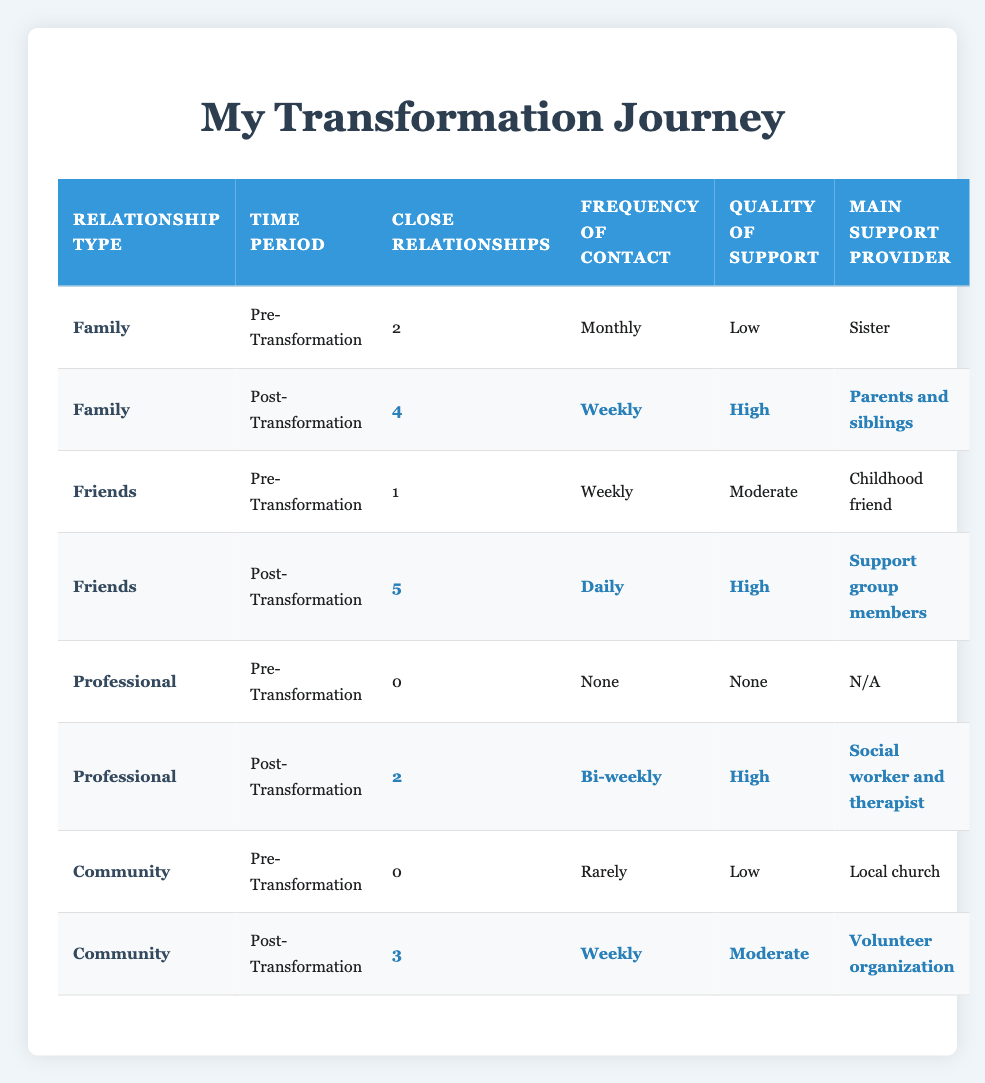What is the frequency of contact for family relationships post-transformation? The table shows that for family relationships post-transformation, the frequency of contact is marked as "Weekly." This can be found in the row for family under the post-transformation section.
Answer: Weekly How many close community relationships were there before the transformation? Looking at the community section under pre-transformation, it states there were "0" close relationships. This value is found in the respective row for community relationships pre-transformation.
Answer: 0 What is the difference in the quality of support for friends pre- and post-transformation? The quality of support for friends pre-transformation is categorized as "Moderate," while post-transformation it is categorized as "High." The difference is between these two qualitative assessments, showing an improvement from "Moderate" to "High."
Answer: Improvement True or False: The number of close professional relationships increased after the transformation. In the pre-transformation section, the number of close professional relationships is "0," and in the post-transformation section, it is "2." This signifies an increase, confirming that the statement is true.
Answer: True What was the total number of close relationships across all categories before the transformation? To find this, we add up the number of close relationships from each category pre-transformation: Family (2) + Friends (1) + Professional (0) + Community (0) = 3. Thus, the total number of close relationships is 3.
Answer: 3 How many types of relationships improved in terms of the frequency of contact after the transformation? By examining the frequency of contact, we note the changes: Family went from Monthly to Weekly, Friends from Weekly to Daily, Professional from None to Bi-weekly, and Community from Rarely to Weekly. Thus, all four relationship types show an improvement in contact frequency post-transformation, leading to a total of 4.
Answer: 4 How many close relationships did I have with friends post-transformation, and who were the main support providers? The table indicates that post-transformation, there are "5" close relationships with friends, with the main support providers being "Support group members." This information is found in the friends section of the post-transformation data.
Answer: 5, Support group members What was the quality of community support after the transformation? In the community section post-transformation, the quality of support is rated as "Moderate." This can be directly referenced from the relevant row in the post-transformation part of the table.
Answer: Moderate 